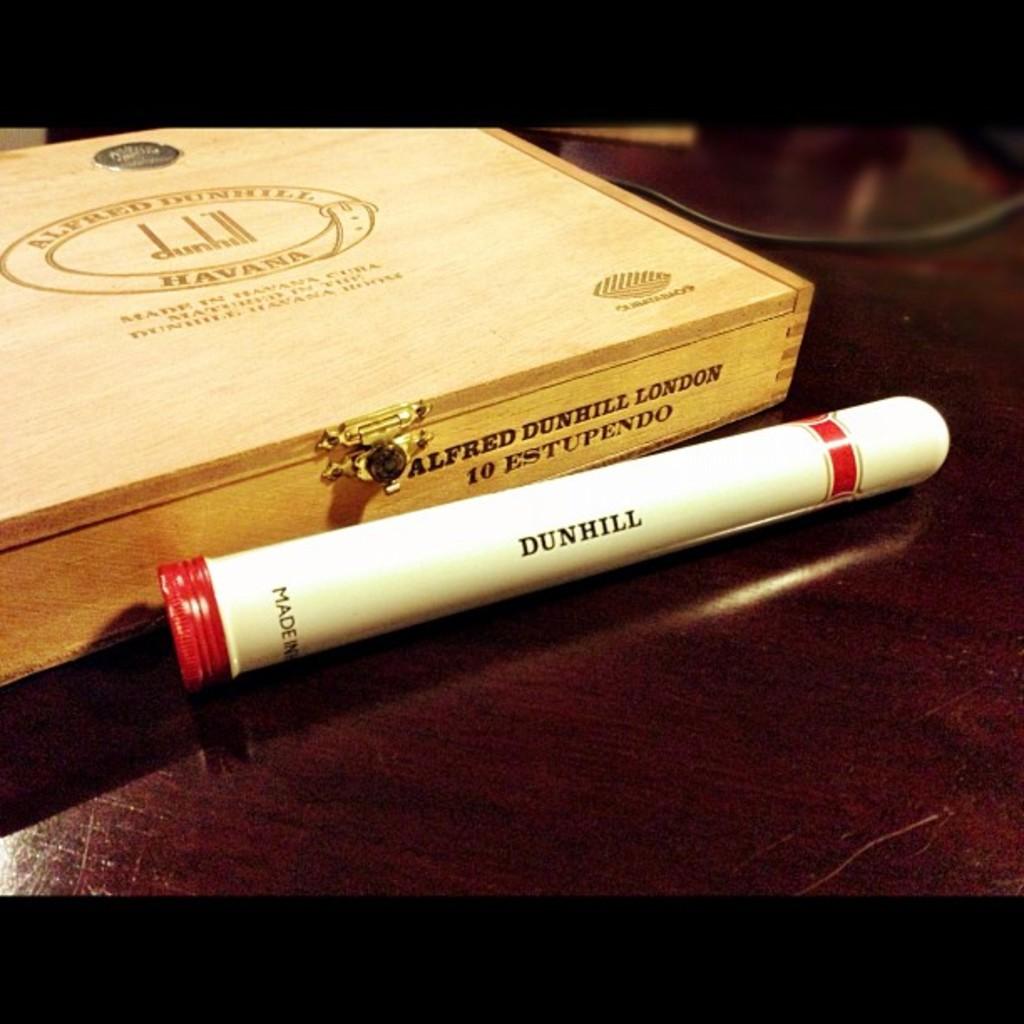Is this a markpen?
Provide a succinct answer. Yes. What cuban city is shown on the box's lid?
Ensure brevity in your answer.  Havana. 